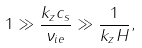<formula> <loc_0><loc_0><loc_500><loc_500>1 \gg \frac { k _ { z } c _ { s } } { \nu _ { i e } } \gg \frac { 1 } { k _ { z } H } ,</formula> 